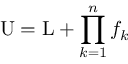Convert formula to latex. <formula><loc_0><loc_0><loc_500><loc_500>U = L + \prod _ { k = 1 } ^ { n } f _ { k }</formula> 